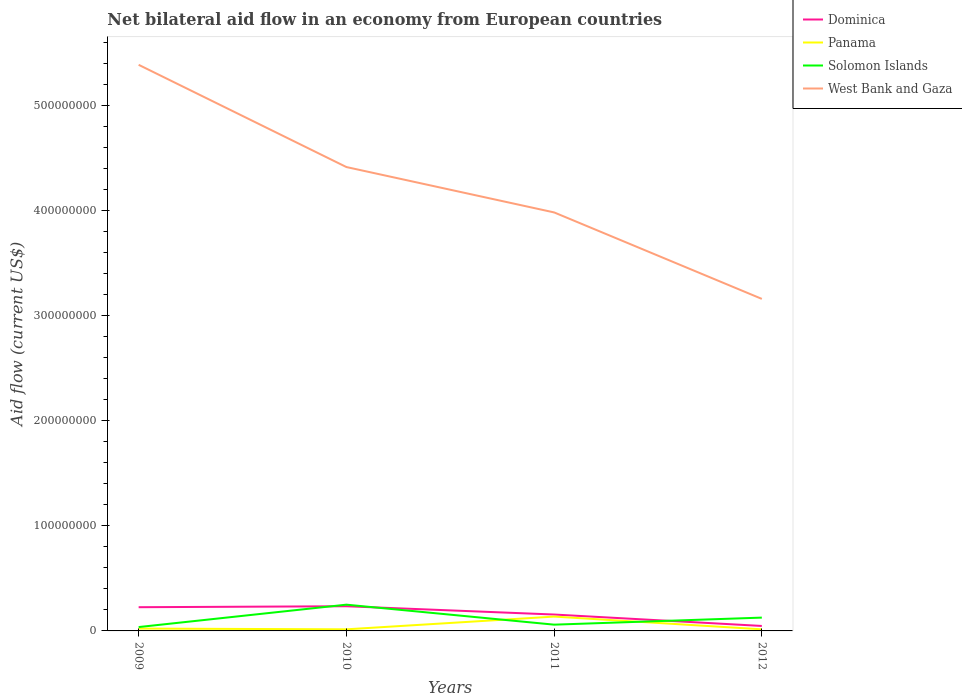How many different coloured lines are there?
Your answer should be compact. 4. Across all years, what is the maximum net bilateral aid flow in Solomon Islands?
Make the answer very short. 3.67e+06. What is the total net bilateral aid flow in West Bank and Gaza in the graph?
Ensure brevity in your answer.  1.25e+08. What is the difference between the highest and the second highest net bilateral aid flow in Panama?
Give a very brief answer. 1.21e+07. Is the net bilateral aid flow in Dominica strictly greater than the net bilateral aid flow in Panama over the years?
Provide a succinct answer. No. How many years are there in the graph?
Provide a short and direct response. 4. Are the values on the major ticks of Y-axis written in scientific E-notation?
Offer a very short reply. No. Does the graph contain any zero values?
Keep it short and to the point. No. Does the graph contain grids?
Your response must be concise. No. How are the legend labels stacked?
Offer a terse response. Vertical. What is the title of the graph?
Keep it short and to the point. Net bilateral aid flow in an economy from European countries. Does "Cote d'Ivoire" appear as one of the legend labels in the graph?
Keep it short and to the point. No. What is the label or title of the X-axis?
Ensure brevity in your answer.  Years. What is the Aid flow (current US$) in Dominica in 2009?
Your answer should be compact. 2.26e+07. What is the Aid flow (current US$) of Panama in 2009?
Keep it short and to the point. 2.23e+06. What is the Aid flow (current US$) of Solomon Islands in 2009?
Provide a short and direct response. 3.67e+06. What is the Aid flow (current US$) of West Bank and Gaza in 2009?
Make the answer very short. 5.38e+08. What is the Aid flow (current US$) in Dominica in 2010?
Provide a short and direct response. 2.35e+07. What is the Aid flow (current US$) in Panama in 2010?
Your answer should be compact. 1.51e+06. What is the Aid flow (current US$) of Solomon Islands in 2010?
Your answer should be compact. 2.50e+07. What is the Aid flow (current US$) in West Bank and Gaza in 2010?
Your answer should be compact. 4.41e+08. What is the Aid flow (current US$) of Dominica in 2011?
Offer a very short reply. 1.56e+07. What is the Aid flow (current US$) in Panama in 2011?
Your answer should be compact. 1.36e+07. What is the Aid flow (current US$) in Solomon Islands in 2011?
Provide a short and direct response. 5.96e+06. What is the Aid flow (current US$) in West Bank and Gaza in 2011?
Provide a short and direct response. 3.98e+08. What is the Aid flow (current US$) of Dominica in 2012?
Offer a terse response. 4.72e+06. What is the Aid flow (current US$) of Panama in 2012?
Ensure brevity in your answer.  1.52e+06. What is the Aid flow (current US$) of Solomon Islands in 2012?
Ensure brevity in your answer.  1.27e+07. What is the Aid flow (current US$) in West Bank and Gaza in 2012?
Provide a succinct answer. 3.16e+08. Across all years, what is the maximum Aid flow (current US$) in Dominica?
Keep it short and to the point. 2.35e+07. Across all years, what is the maximum Aid flow (current US$) in Panama?
Make the answer very short. 1.36e+07. Across all years, what is the maximum Aid flow (current US$) in Solomon Islands?
Provide a succinct answer. 2.50e+07. Across all years, what is the maximum Aid flow (current US$) in West Bank and Gaza?
Your answer should be compact. 5.38e+08. Across all years, what is the minimum Aid flow (current US$) in Dominica?
Offer a very short reply. 4.72e+06. Across all years, what is the minimum Aid flow (current US$) in Panama?
Make the answer very short. 1.51e+06. Across all years, what is the minimum Aid flow (current US$) of Solomon Islands?
Your answer should be very brief. 3.67e+06. Across all years, what is the minimum Aid flow (current US$) of West Bank and Gaza?
Offer a very short reply. 3.16e+08. What is the total Aid flow (current US$) of Dominica in the graph?
Ensure brevity in your answer.  6.63e+07. What is the total Aid flow (current US$) in Panama in the graph?
Keep it short and to the point. 1.89e+07. What is the total Aid flow (current US$) in Solomon Islands in the graph?
Make the answer very short. 4.73e+07. What is the total Aid flow (current US$) of West Bank and Gaza in the graph?
Your response must be concise. 1.69e+09. What is the difference between the Aid flow (current US$) of Dominica in 2009 and that in 2010?
Offer a very short reply. -9.10e+05. What is the difference between the Aid flow (current US$) in Panama in 2009 and that in 2010?
Provide a short and direct response. 7.20e+05. What is the difference between the Aid flow (current US$) in Solomon Islands in 2009 and that in 2010?
Offer a terse response. -2.13e+07. What is the difference between the Aid flow (current US$) of West Bank and Gaza in 2009 and that in 2010?
Provide a succinct answer. 9.72e+07. What is the difference between the Aid flow (current US$) of Dominica in 2009 and that in 2011?
Give a very brief answer. 6.96e+06. What is the difference between the Aid flow (current US$) in Panama in 2009 and that in 2011?
Provide a short and direct response. -1.14e+07. What is the difference between the Aid flow (current US$) in Solomon Islands in 2009 and that in 2011?
Your answer should be very brief. -2.29e+06. What is the difference between the Aid flow (current US$) in West Bank and Gaza in 2009 and that in 2011?
Make the answer very short. 1.40e+08. What is the difference between the Aid flow (current US$) in Dominica in 2009 and that in 2012?
Offer a very short reply. 1.78e+07. What is the difference between the Aid flow (current US$) in Panama in 2009 and that in 2012?
Offer a very short reply. 7.10e+05. What is the difference between the Aid flow (current US$) in Solomon Islands in 2009 and that in 2012?
Your response must be concise. -8.99e+06. What is the difference between the Aid flow (current US$) of West Bank and Gaza in 2009 and that in 2012?
Your answer should be very brief. 2.23e+08. What is the difference between the Aid flow (current US$) in Dominica in 2010 and that in 2011?
Give a very brief answer. 7.87e+06. What is the difference between the Aid flow (current US$) in Panama in 2010 and that in 2011?
Keep it short and to the point. -1.21e+07. What is the difference between the Aid flow (current US$) of Solomon Islands in 2010 and that in 2011?
Offer a very short reply. 1.90e+07. What is the difference between the Aid flow (current US$) in West Bank and Gaza in 2010 and that in 2011?
Keep it short and to the point. 4.31e+07. What is the difference between the Aid flow (current US$) in Dominica in 2010 and that in 2012?
Provide a succinct answer. 1.87e+07. What is the difference between the Aid flow (current US$) in Panama in 2010 and that in 2012?
Provide a succinct answer. -10000. What is the difference between the Aid flow (current US$) in Solomon Islands in 2010 and that in 2012?
Give a very brief answer. 1.23e+07. What is the difference between the Aid flow (current US$) of West Bank and Gaza in 2010 and that in 2012?
Ensure brevity in your answer.  1.25e+08. What is the difference between the Aid flow (current US$) in Dominica in 2011 and that in 2012?
Keep it short and to the point. 1.09e+07. What is the difference between the Aid flow (current US$) in Panama in 2011 and that in 2012?
Offer a very short reply. 1.21e+07. What is the difference between the Aid flow (current US$) in Solomon Islands in 2011 and that in 2012?
Provide a succinct answer. -6.70e+06. What is the difference between the Aid flow (current US$) of West Bank and Gaza in 2011 and that in 2012?
Ensure brevity in your answer.  8.22e+07. What is the difference between the Aid flow (current US$) of Dominica in 2009 and the Aid flow (current US$) of Panama in 2010?
Your answer should be very brief. 2.10e+07. What is the difference between the Aid flow (current US$) of Dominica in 2009 and the Aid flow (current US$) of Solomon Islands in 2010?
Provide a short and direct response. -2.42e+06. What is the difference between the Aid flow (current US$) of Dominica in 2009 and the Aid flow (current US$) of West Bank and Gaza in 2010?
Provide a short and direct response. -4.19e+08. What is the difference between the Aid flow (current US$) of Panama in 2009 and the Aid flow (current US$) of Solomon Islands in 2010?
Provide a succinct answer. -2.27e+07. What is the difference between the Aid flow (current US$) in Panama in 2009 and the Aid flow (current US$) in West Bank and Gaza in 2010?
Your response must be concise. -4.39e+08. What is the difference between the Aid flow (current US$) of Solomon Islands in 2009 and the Aid flow (current US$) of West Bank and Gaza in 2010?
Provide a short and direct response. -4.37e+08. What is the difference between the Aid flow (current US$) in Dominica in 2009 and the Aid flow (current US$) in Panama in 2011?
Keep it short and to the point. 8.92e+06. What is the difference between the Aid flow (current US$) of Dominica in 2009 and the Aid flow (current US$) of Solomon Islands in 2011?
Ensure brevity in your answer.  1.66e+07. What is the difference between the Aid flow (current US$) in Dominica in 2009 and the Aid flow (current US$) in West Bank and Gaza in 2011?
Provide a short and direct response. -3.75e+08. What is the difference between the Aid flow (current US$) of Panama in 2009 and the Aid flow (current US$) of Solomon Islands in 2011?
Provide a short and direct response. -3.73e+06. What is the difference between the Aid flow (current US$) in Panama in 2009 and the Aid flow (current US$) in West Bank and Gaza in 2011?
Make the answer very short. -3.96e+08. What is the difference between the Aid flow (current US$) of Solomon Islands in 2009 and the Aid flow (current US$) of West Bank and Gaza in 2011?
Keep it short and to the point. -3.94e+08. What is the difference between the Aid flow (current US$) of Dominica in 2009 and the Aid flow (current US$) of Panama in 2012?
Offer a terse response. 2.10e+07. What is the difference between the Aid flow (current US$) of Dominica in 2009 and the Aid flow (current US$) of Solomon Islands in 2012?
Your response must be concise. 9.89e+06. What is the difference between the Aid flow (current US$) of Dominica in 2009 and the Aid flow (current US$) of West Bank and Gaza in 2012?
Your answer should be compact. -2.93e+08. What is the difference between the Aid flow (current US$) of Panama in 2009 and the Aid flow (current US$) of Solomon Islands in 2012?
Ensure brevity in your answer.  -1.04e+07. What is the difference between the Aid flow (current US$) of Panama in 2009 and the Aid flow (current US$) of West Bank and Gaza in 2012?
Keep it short and to the point. -3.13e+08. What is the difference between the Aid flow (current US$) of Solomon Islands in 2009 and the Aid flow (current US$) of West Bank and Gaza in 2012?
Ensure brevity in your answer.  -3.12e+08. What is the difference between the Aid flow (current US$) in Dominica in 2010 and the Aid flow (current US$) in Panama in 2011?
Your response must be concise. 9.83e+06. What is the difference between the Aid flow (current US$) of Dominica in 2010 and the Aid flow (current US$) of Solomon Islands in 2011?
Offer a terse response. 1.75e+07. What is the difference between the Aid flow (current US$) of Dominica in 2010 and the Aid flow (current US$) of West Bank and Gaza in 2011?
Keep it short and to the point. -3.74e+08. What is the difference between the Aid flow (current US$) of Panama in 2010 and the Aid flow (current US$) of Solomon Islands in 2011?
Offer a very short reply. -4.45e+06. What is the difference between the Aid flow (current US$) in Panama in 2010 and the Aid flow (current US$) in West Bank and Gaza in 2011?
Your answer should be compact. -3.96e+08. What is the difference between the Aid flow (current US$) of Solomon Islands in 2010 and the Aid flow (current US$) of West Bank and Gaza in 2011?
Provide a succinct answer. -3.73e+08. What is the difference between the Aid flow (current US$) of Dominica in 2010 and the Aid flow (current US$) of Panama in 2012?
Make the answer very short. 2.19e+07. What is the difference between the Aid flow (current US$) of Dominica in 2010 and the Aid flow (current US$) of Solomon Islands in 2012?
Ensure brevity in your answer.  1.08e+07. What is the difference between the Aid flow (current US$) of Dominica in 2010 and the Aid flow (current US$) of West Bank and Gaza in 2012?
Make the answer very short. -2.92e+08. What is the difference between the Aid flow (current US$) of Panama in 2010 and the Aid flow (current US$) of Solomon Islands in 2012?
Offer a terse response. -1.12e+07. What is the difference between the Aid flow (current US$) in Panama in 2010 and the Aid flow (current US$) in West Bank and Gaza in 2012?
Keep it short and to the point. -3.14e+08. What is the difference between the Aid flow (current US$) of Solomon Islands in 2010 and the Aid flow (current US$) of West Bank and Gaza in 2012?
Offer a terse response. -2.91e+08. What is the difference between the Aid flow (current US$) in Dominica in 2011 and the Aid flow (current US$) in Panama in 2012?
Your answer should be very brief. 1.41e+07. What is the difference between the Aid flow (current US$) in Dominica in 2011 and the Aid flow (current US$) in Solomon Islands in 2012?
Offer a terse response. 2.93e+06. What is the difference between the Aid flow (current US$) of Dominica in 2011 and the Aid flow (current US$) of West Bank and Gaza in 2012?
Offer a very short reply. -3.00e+08. What is the difference between the Aid flow (current US$) in Panama in 2011 and the Aid flow (current US$) in Solomon Islands in 2012?
Provide a short and direct response. 9.70e+05. What is the difference between the Aid flow (current US$) in Panama in 2011 and the Aid flow (current US$) in West Bank and Gaza in 2012?
Provide a short and direct response. -3.02e+08. What is the difference between the Aid flow (current US$) of Solomon Islands in 2011 and the Aid flow (current US$) of West Bank and Gaza in 2012?
Your answer should be compact. -3.10e+08. What is the average Aid flow (current US$) of Dominica per year?
Provide a short and direct response. 1.66e+07. What is the average Aid flow (current US$) of Panama per year?
Provide a succinct answer. 4.72e+06. What is the average Aid flow (current US$) of Solomon Islands per year?
Provide a succinct answer. 1.18e+07. What is the average Aid flow (current US$) in West Bank and Gaza per year?
Your response must be concise. 4.23e+08. In the year 2009, what is the difference between the Aid flow (current US$) in Dominica and Aid flow (current US$) in Panama?
Offer a very short reply. 2.03e+07. In the year 2009, what is the difference between the Aid flow (current US$) of Dominica and Aid flow (current US$) of Solomon Islands?
Provide a succinct answer. 1.89e+07. In the year 2009, what is the difference between the Aid flow (current US$) in Dominica and Aid flow (current US$) in West Bank and Gaza?
Ensure brevity in your answer.  -5.16e+08. In the year 2009, what is the difference between the Aid flow (current US$) of Panama and Aid flow (current US$) of Solomon Islands?
Offer a very short reply. -1.44e+06. In the year 2009, what is the difference between the Aid flow (current US$) of Panama and Aid flow (current US$) of West Bank and Gaza?
Ensure brevity in your answer.  -5.36e+08. In the year 2009, what is the difference between the Aid flow (current US$) in Solomon Islands and Aid flow (current US$) in West Bank and Gaza?
Give a very brief answer. -5.35e+08. In the year 2010, what is the difference between the Aid flow (current US$) in Dominica and Aid flow (current US$) in Panama?
Provide a succinct answer. 2.20e+07. In the year 2010, what is the difference between the Aid flow (current US$) in Dominica and Aid flow (current US$) in Solomon Islands?
Make the answer very short. -1.51e+06. In the year 2010, what is the difference between the Aid flow (current US$) in Dominica and Aid flow (current US$) in West Bank and Gaza?
Your answer should be compact. -4.18e+08. In the year 2010, what is the difference between the Aid flow (current US$) in Panama and Aid flow (current US$) in Solomon Islands?
Your response must be concise. -2.35e+07. In the year 2010, what is the difference between the Aid flow (current US$) of Panama and Aid flow (current US$) of West Bank and Gaza?
Your response must be concise. -4.40e+08. In the year 2010, what is the difference between the Aid flow (current US$) in Solomon Islands and Aid flow (current US$) in West Bank and Gaza?
Offer a terse response. -4.16e+08. In the year 2011, what is the difference between the Aid flow (current US$) in Dominica and Aid flow (current US$) in Panama?
Your response must be concise. 1.96e+06. In the year 2011, what is the difference between the Aid flow (current US$) in Dominica and Aid flow (current US$) in Solomon Islands?
Give a very brief answer. 9.63e+06. In the year 2011, what is the difference between the Aid flow (current US$) of Dominica and Aid flow (current US$) of West Bank and Gaza?
Give a very brief answer. -3.82e+08. In the year 2011, what is the difference between the Aid flow (current US$) in Panama and Aid flow (current US$) in Solomon Islands?
Your response must be concise. 7.67e+06. In the year 2011, what is the difference between the Aid flow (current US$) of Panama and Aid flow (current US$) of West Bank and Gaza?
Provide a succinct answer. -3.84e+08. In the year 2011, what is the difference between the Aid flow (current US$) in Solomon Islands and Aid flow (current US$) in West Bank and Gaza?
Keep it short and to the point. -3.92e+08. In the year 2012, what is the difference between the Aid flow (current US$) in Dominica and Aid flow (current US$) in Panama?
Provide a succinct answer. 3.20e+06. In the year 2012, what is the difference between the Aid flow (current US$) in Dominica and Aid flow (current US$) in Solomon Islands?
Offer a very short reply. -7.94e+06. In the year 2012, what is the difference between the Aid flow (current US$) in Dominica and Aid flow (current US$) in West Bank and Gaza?
Your response must be concise. -3.11e+08. In the year 2012, what is the difference between the Aid flow (current US$) in Panama and Aid flow (current US$) in Solomon Islands?
Make the answer very short. -1.11e+07. In the year 2012, what is the difference between the Aid flow (current US$) in Panama and Aid flow (current US$) in West Bank and Gaza?
Offer a very short reply. -3.14e+08. In the year 2012, what is the difference between the Aid flow (current US$) in Solomon Islands and Aid flow (current US$) in West Bank and Gaza?
Give a very brief answer. -3.03e+08. What is the ratio of the Aid flow (current US$) in Dominica in 2009 to that in 2010?
Give a very brief answer. 0.96. What is the ratio of the Aid flow (current US$) in Panama in 2009 to that in 2010?
Provide a short and direct response. 1.48. What is the ratio of the Aid flow (current US$) in Solomon Islands in 2009 to that in 2010?
Ensure brevity in your answer.  0.15. What is the ratio of the Aid flow (current US$) in West Bank and Gaza in 2009 to that in 2010?
Keep it short and to the point. 1.22. What is the ratio of the Aid flow (current US$) in Dominica in 2009 to that in 2011?
Ensure brevity in your answer.  1.45. What is the ratio of the Aid flow (current US$) in Panama in 2009 to that in 2011?
Provide a succinct answer. 0.16. What is the ratio of the Aid flow (current US$) in Solomon Islands in 2009 to that in 2011?
Your answer should be very brief. 0.62. What is the ratio of the Aid flow (current US$) in West Bank and Gaza in 2009 to that in 2011?
Give a very brief answer. 1.35. What is the ratio of the Aid flow (current US$) in Dominica in 2009 to that in 2012?
Ensure brevity in your answer.  4.78. What is the ratio of the Aid flow (current US$) of Panama in 2009 to that in 2012?
Your answer should be compact. 1.47. What is the ratio of the Aid flow (current US$) of Solomon Islands in 2009 to that in 2012?
Provide a succinct answer. 0.29. What is the ratio of the Aid flow (current US$) in West Bank and Gaza in 2009 to that in 2012?
Ensure brevity in your answer.  1.71. What is the ratio of the Aid flow (current US$) of Dominica in 2010 to that in 2011?
Make the answer very short. 1.5. What is the ratio of the Aid flow (current US$) in Panama in 2010 to that in 2011?
Make the answer very short. 0.11. What is the ratio of the Aid flow (current US$) of Solomon Islands in 2010 to that in 2011?
Offer a very short reply. 4.19. What is the ratio of the Aid flow (current US$) of West Bank and Gaza in 2010 to that in 2011?
Make the answer very short. 1.11. What is the ratio of the Aid flow (current US$) in Dominica in 2010 to that in 2012?
Provide a short and direct response. 4.97. What is the ratio of the Aid flow (current US$) of Panama in 2010 to that in 2012?
Give a very brief answer. 0.99. What is the ratio of the Aid flow (current US$) in Solomon Islands in 2010 to that in 2012?
Keep it short and to the point. 1.97. What is the ratio of the Aid flow (current US$) in West Bank and Gaza in 2010 to that in 2012?
Your response must be concise. 1.4. What is the ratio of the Aid flow (current US$) in Dominica in 2011 to that in 2012?
Keep it short and to the point. 3.3. What is the ratio of the Aid flow (current US$) of Panama in 2011 to that in 2012?
Make the answer very short. 8.97. What is the ratio of the Aid flow (current US$) in Solomon Islands in 2011 to that in 2012?
Provide a short and direct response. 0.47. What is the ratio of the Aid flow (current US$) in West Bank and Gaza in 2011 to that in 2012?
Keep it short and to the point. 1.26. What is the difference between the highest and the second highest Aid flow (current US$) in Dominica?
Make the answer very short. 9.10e+05. What is the difference between the highest and the second highest Aid flow (current US$) of Panama?
Offer a terse response. 1.14e+07. What is the difference between the highest and the second highest Aid flow (current US$) in Solomon Islands?
Your answer should be very brief. 1.23e+07. What is the difference between the highest and the second highest Aid flow (current US$) of West Bank and Gaza?
Your answer should be very brief. 9.72e+07. What is the difference between the highest and the lowest Aid flow (current US$) in Dominica?
Your answer should be compact. 1.87e+07. What is the difference between the highest and the lowest Aid flow (current US$) of Panama?
Offer a terse response. 1.21e+07. What is the difference between the highest and the lowest Aid flow (current US$) of Solomon Islands?
Provide a succinct answer. 2.13e+07. What is the difference between the highest and the lowest Aid flow (current US$) in West Bank and Gaza?
Provide a succinct answer. 2.23e+08. 